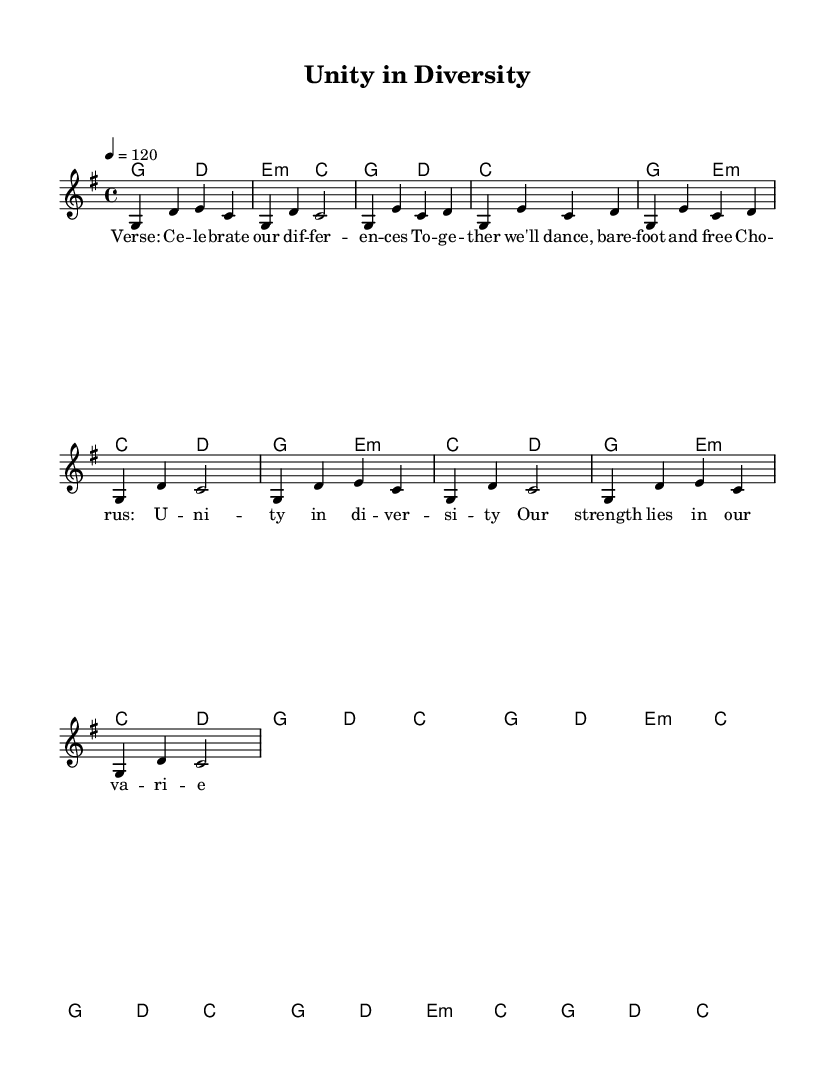What is the key signature of this music? The key signature is G major, which has one sharp (F#). It's indicated at the beginning of the score.
Answer: G major What is the time signature of this music? The time signature at the beginning of the score is 4/4, meaning there are four beats in each measure.
Answer: 4/4 What is the tempo marking for this piece? The tempo marking states "4 = 120," indicating a moderate tempo of 120 beats per minute.
Answer: 120 How many measures are in the verse section? The verse section consists of four measures, as identifiable by the measure lines.
Answer: 4 What is the primary theme of the chorus? The chorus emphasizes "Unity in diversity," showcasing a message of strength through variety, as conveyed in the lyrics.
Answer: Unity in diversity How do the harmonies in the chorus relate to the melody? The harmonies in the chorus support the melody by providing chord progressions that complement the melodic notes played, with the same rhythmic structure.
Answer: Complementary How does the structure of this piece reflect folk music traditions? The structure includes clear verses and a repeating chorus, which is common in folk music, promoting communal singing and celebration of cultural diversity.
Answer: Community and celebration 